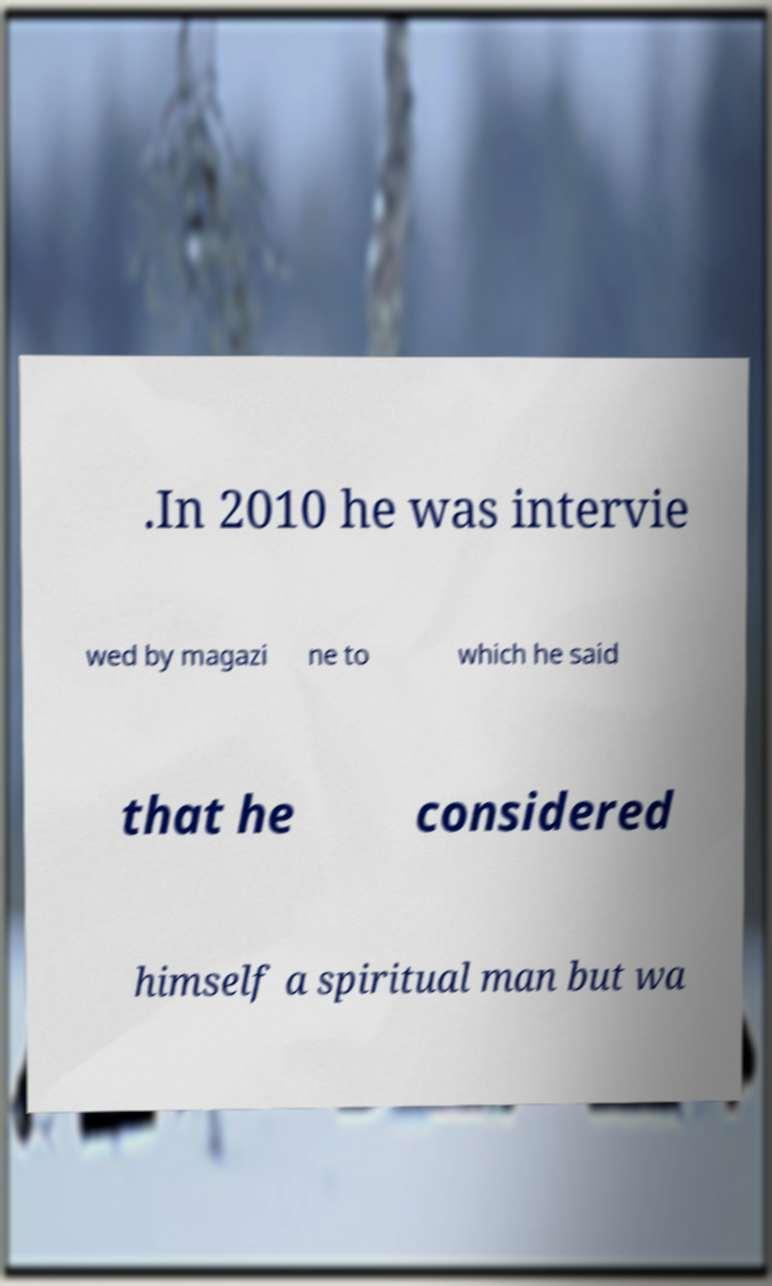Please identify and transcribe the text found in this image. .In 2010 he was intervie wed by magazi ne to which he said that he considered himself a spiritual man but wa 